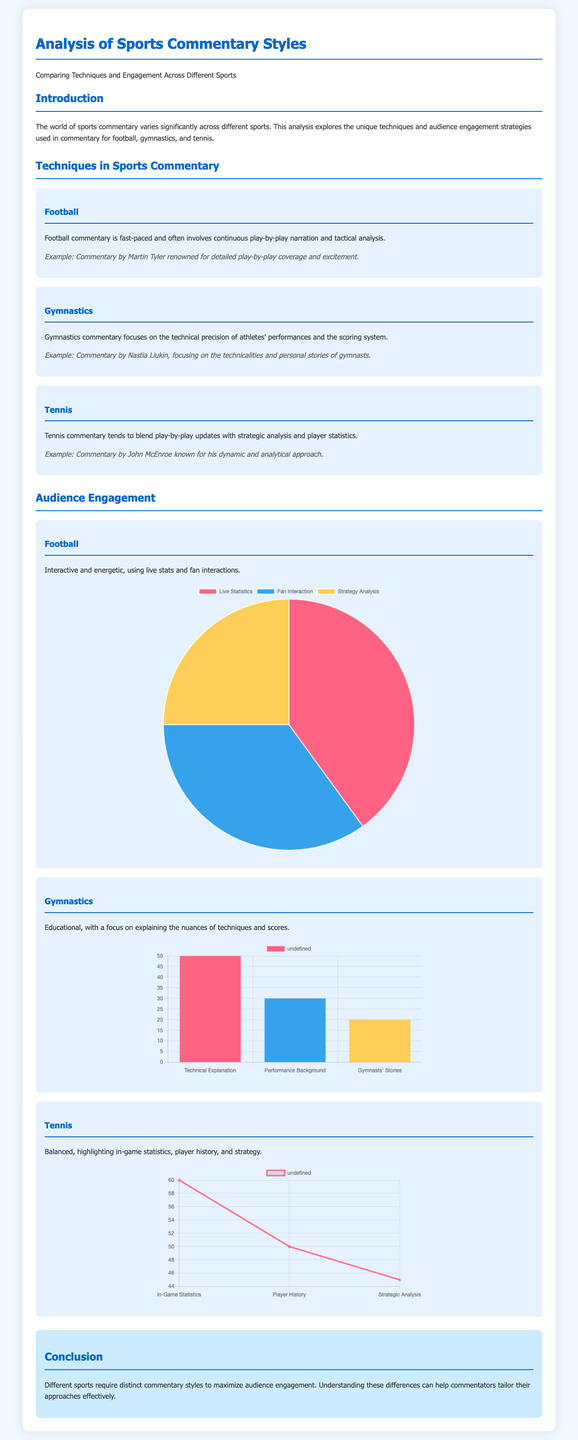What are the three sports analyzed in the document? The document specifically analyzes football, gymnastics, and tennis as the three sports.
Answer: football, gymnastics, tennis Who is a renowned football commentator mentioned in the document? The document cites Martin Tyler as a renowned football commentator known for detailed coverage.
Answer: Martin Tyler What is the primary focus of gymnastics commentary according to the document? The document states that gymnastics commentary focuses on the technical precision of athletes' performances and the scoring system.
Answer: Technical precision What is the engagement technique that has the highest percentage in football commentary? The football chart in the document indicates that Live Statistics is the engagement technique with the highest percentage at 40%.
Answer: Live Statistics Which commentator is known for a dynamic and analytical approach in tennis? John McEnroe is identified in the document as the commentator known for his dynamic and analytical approach in tennis.
Answer: John McEnroe What percentage of audience engagement in gymnastics commentary is dedicated to Technical Explanation? The gymnastics chart shows that 50% of audience engagement is dedicated to Technical Explanation in gymnastics commentary.
Answer: 50% What kind of chart represents the engagement techniques in football commentary? The document illustrates the engagement techniques in football commentary using a pie chart.
Answer: Pie chart Which aspect has the lowest engagement in gymnastics commentary? According to the gymnastics chart, the aspect with the lowest engagement is Gymnasts' Stories at 20%.
Answer: Gymnasts' Stories What is the color used for In-Game Statistics in the tennis chart? The tennis chart uses the color #FF6384 for In-Game Statistics.
Answer: #FF6384 